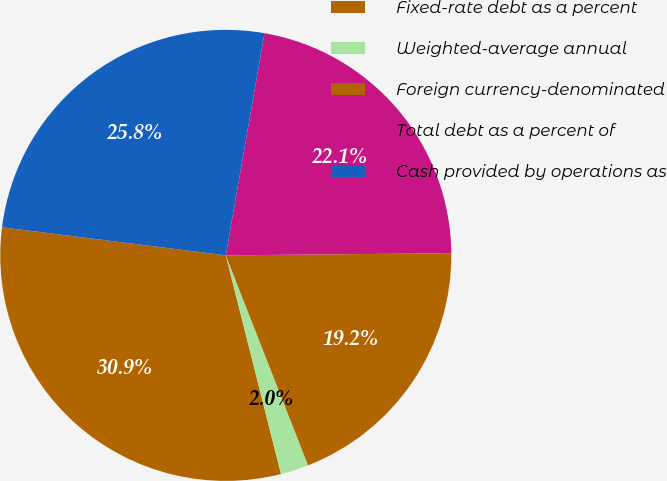<chart> <loc_0><loc_0><loc_500><loc_500><pie_chart><fcel>Fixed-rate debt as a percent<fcel>Weighted-average annual<fcel>Foreign currency-denominated<fcel>Total debt as a percent of<fcel>Cash provided by operations as<nl><fcel>30.92%<fcel>2.01%<fcel>19.21%<fcel>22.1%<fcel>25.76%<nl></chart> 